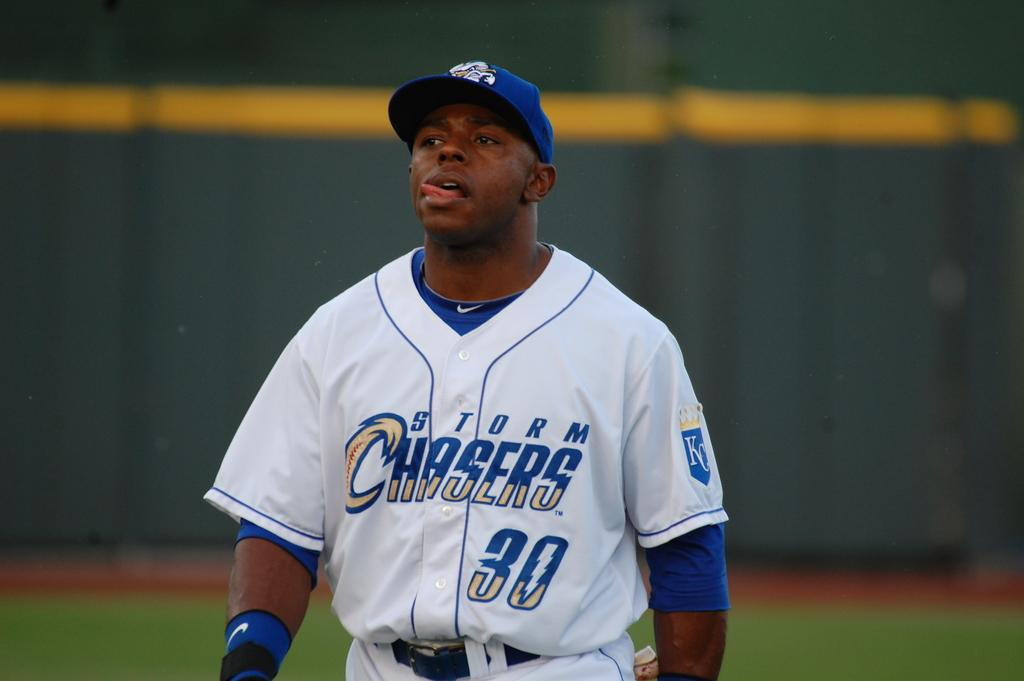<image>
Write a terse but informative summary of the picture. A player is wearing a Storm Chasers jersey with the number 30 on it 